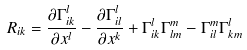<formula> <loc_0><loc_0><loc_500><loc_500>R _ { i k } = \frac { \partial \Gamma _ { i k } ^ { l } } { \partial x ^ { l } } - \frac { \partial \Gamma _ { i l } ^ { l } } { \partial x ^ { k } } + \Gamma _ { i k } ^ { l } \Gamma _ { l m } ^ { m } - \Gamma _ { i l } ^ { m } \Gamma _ { k m } ^ { l } \text { \quad }</formula> 